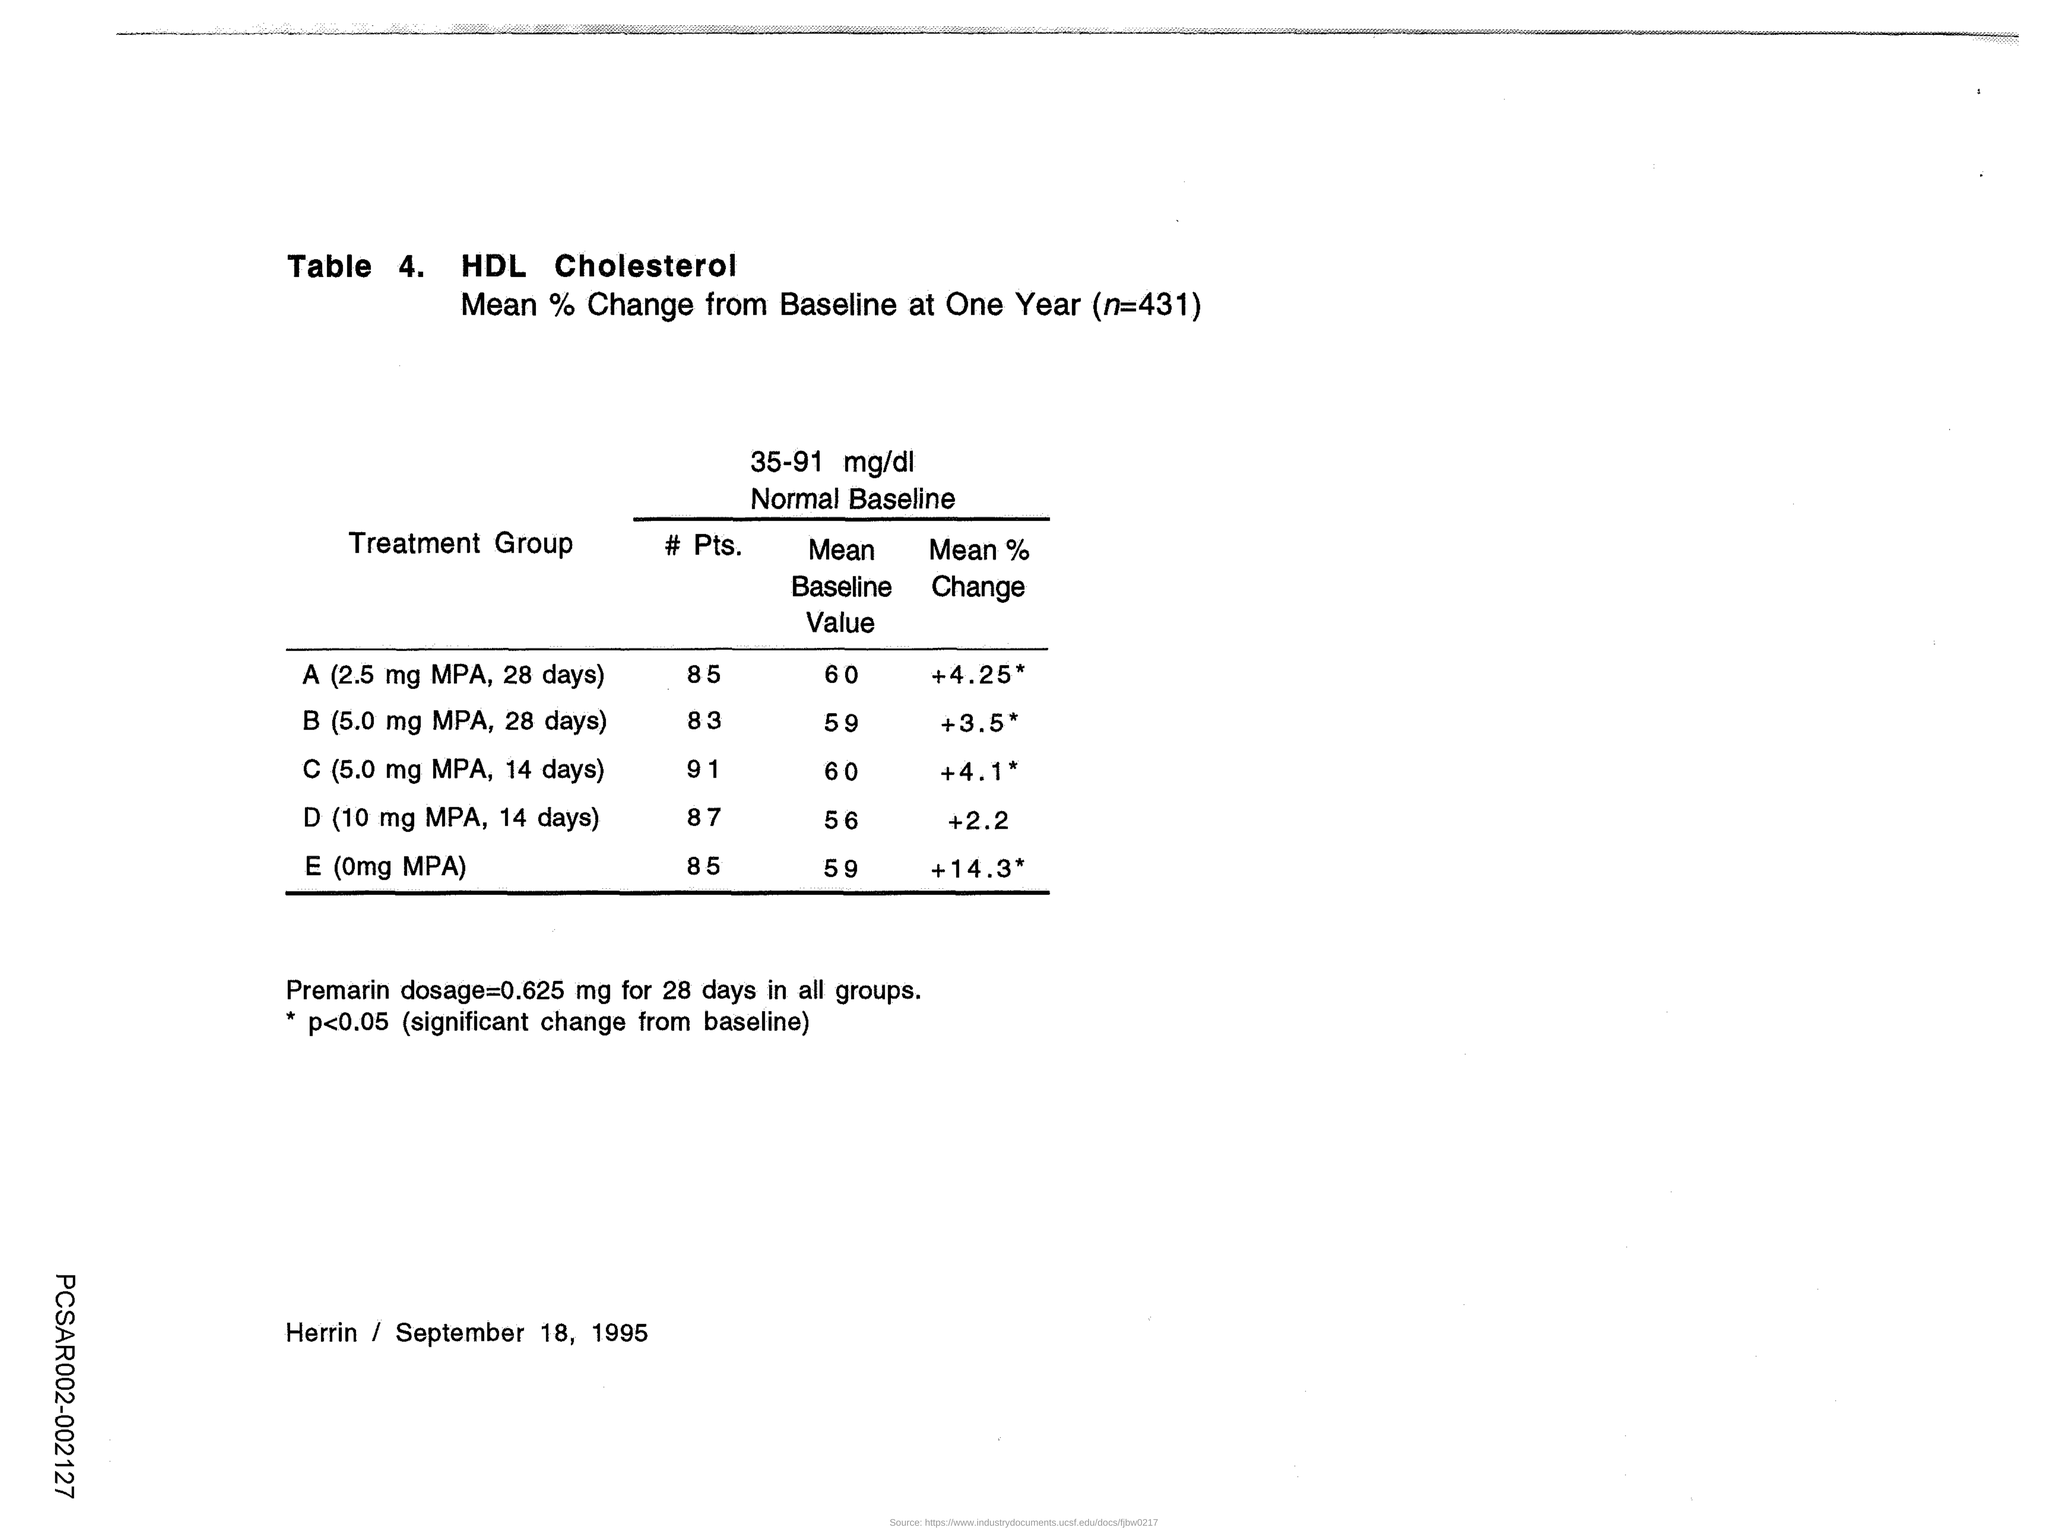What is the "Table" number mentioned here?
Provide a short and direct response. 4. What is the value of "n" given at the top of the table?
Your answer should be compact. 431. What is the "Mean Baseline Value" of "A (2.5 mg MPA, 28 days)" Treatment Group?
Provide a succinct answer. 60. What is the second "Treatment Group" mentioned in the table?
Ensure brevity in your answer.  B (5.0 mg MPA, 28 days). What is the "Mean Baseline Value" of "B (5.0 mg MPA, 28 days)" Treatment Group?
Make the answer very short. 59. What is the "Mean % Change " of "D ( 10 mg MPA, 14 days)" Treatment Group?
Ensure brevity in your answer.  +2.2. What is the "Mean Baseline Value" of "C (5.0 mg MPA, 14 days)" Treatment Group?
Provide a short and direct response. 60. What is the "Premarin dosage" for 28 days in all groups?
Provide a succinct answer. 0.625 mg. 